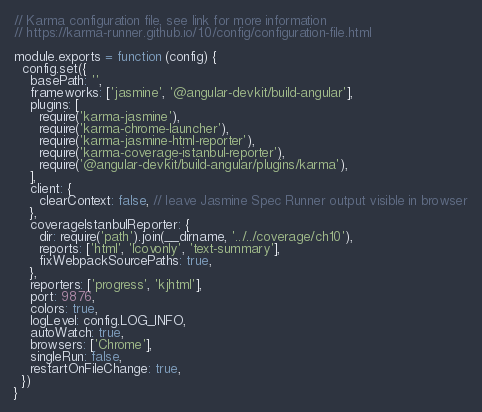Convert code to text. <code><loc_0><loc_0><loc_500><loc_500><_JavaScript_>// Karma configuration file, see link for more information
// https://karma-runner.github.io/1.0/config/configuration-file.html

module.exports = function (config) {
  config.set({
    basePath: '',
    frameworks: ['jasmine', '@angular-devkit/build-angular'],
    plugins: [
      require('karma-jasmine'),
      require('karma-chrome-launcher'),
      require('karma-jasmine-html-reporter'),
      require('karma-coverage-istanbul-reporter'),
      require('@angular-devkit/build-angular/plugins/karma'),
    ],
    client: {
      clearContext: false, // leave Jasmine Spec Runner output visible in browser
    },
    coverageIstanbulReporter: {
      dir: require('path').join(__dirname, '../../coverage/ch10'),
      reports: ['html', 'lcovonly', 'text-summary'],
      fixWebpackSourcePaths: true,
    },
    reporters: ['progress', 'kjhtml'],
    port: 9876,
    colors: true,
    logLevel: config.LOG_INFO,
    autoWatch: true,
    browsers: ['Chrome'],
    singleRun: false,
    restartOnFileChange: true,
  })
}
</code> 